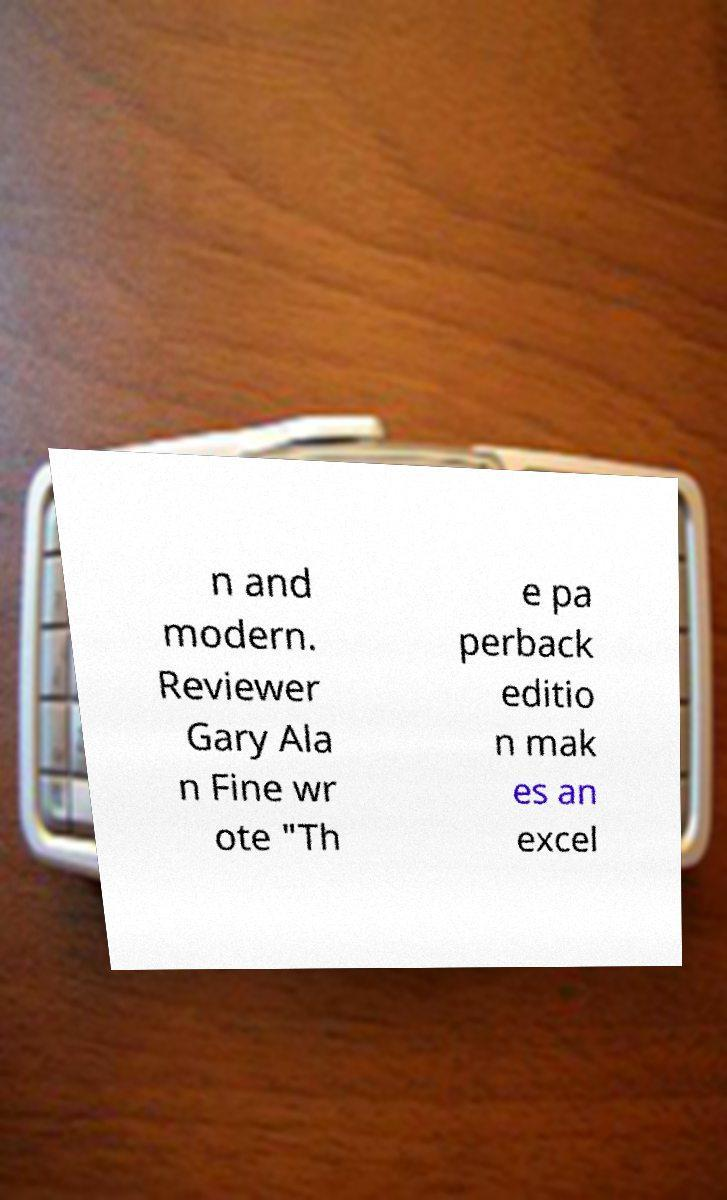I need the written content from this picture converted into text. Can you do that? n and modern. Reviewer Gary Ala n Fine wr ote "Th e pa perback editio n mak es an excel 